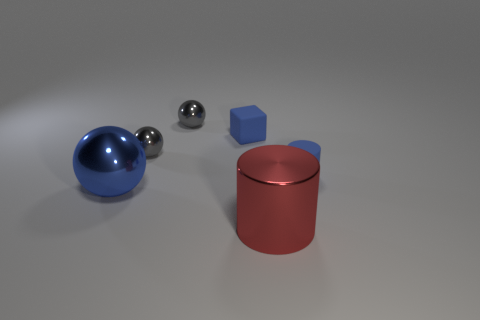What number of cylinders are behind the large red metal thing?
Your answer should be compact. 1. Is the number of tiny rubber things in front of the big metal cylinder less than the number of big metal blocks?
Ensure brevity in your answer.  No. What color is the small cylinder?
Your answer should be compact. Blue. Do the rubber object that is to the right of the red object and the tiny rubber cube have the same color?
Make the answer very short. Yes. What color is the other tiny object that is the same shape as the red shiny thing?
Make the answer very short. Blue. What number of small objects are either metal cylinders or gray balls?
Your answer should be very brief. 2. How big is the cylinder that is behind the large shiny ball?
Ensure brevity in your answer.  Small. Are there any small matte cubes of the same color as the big shiny cylinder?
Ensure brevity in your answer.  No. Do the matte block and the small matte cylinder have the same color?
Your answer should be very brief. Yes. What shape is the small thing that is the same color as the small cylinder?
Offer a very short reply. Cube. 